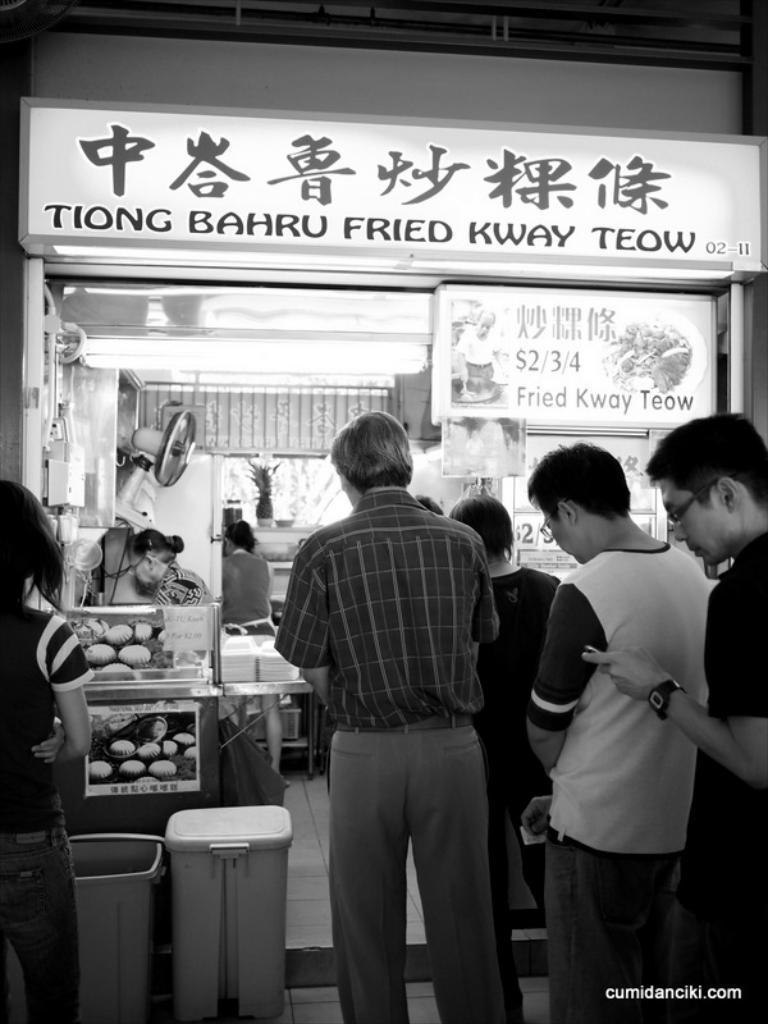Provide a one-sentence caption for the provided image. The front of a restaurant that sells fried food. 